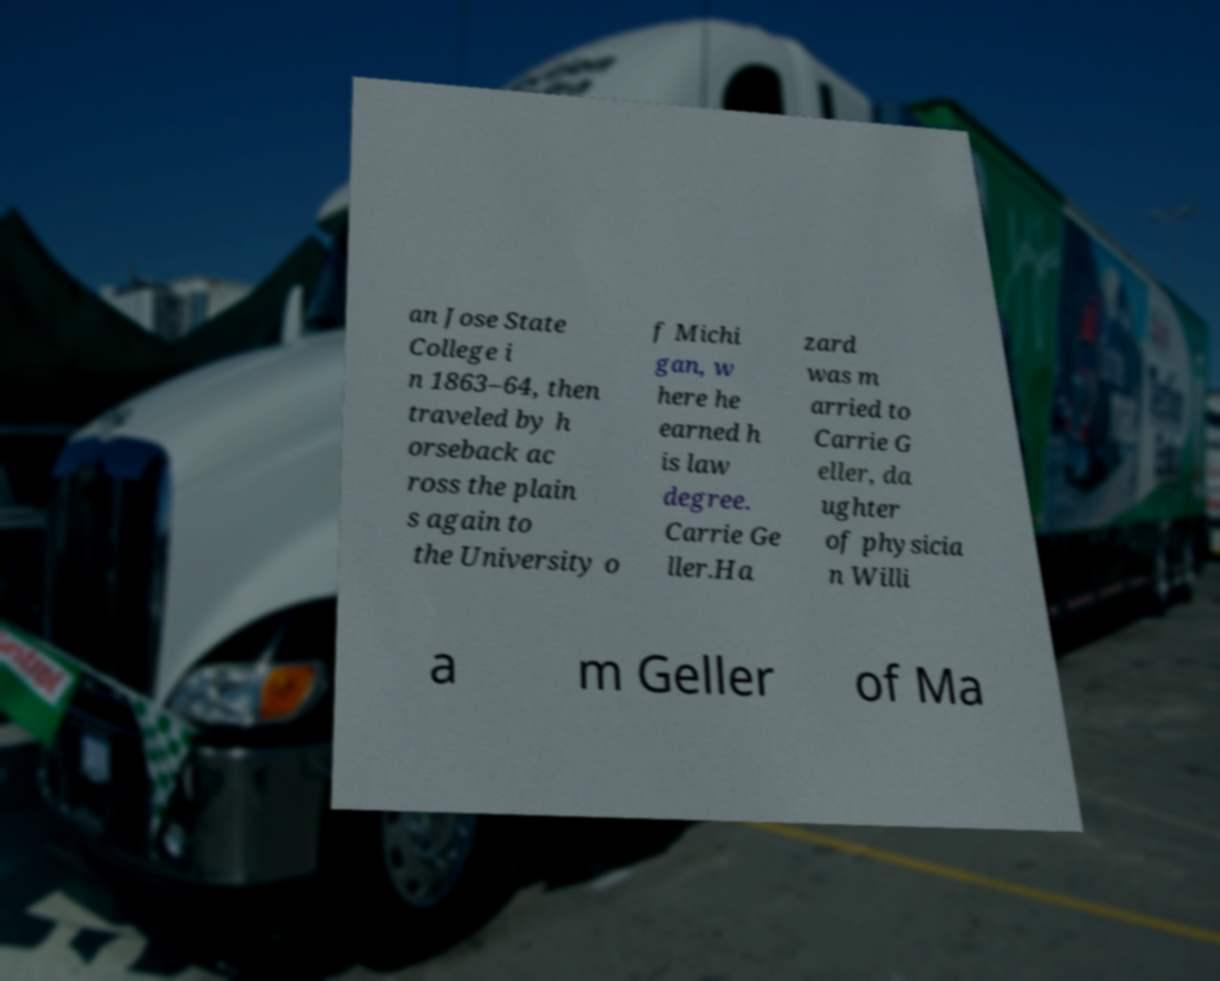Could you assist in decoding the text presented in this image and type it out clearly? an Jose State College i n 1863–64, then traveled by h orseback ac ross the plain s again to the University o f Michi gan, w here he earned h is law degree. Carrie Ge ller.Ha zard was m arried to Carrie G eller, da ughter of physicia n Willi a m Geller of Ma 